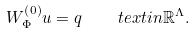<formula> <loc_0><loc_0><loc_500><loc_500>W _ { \Phi } ^ { \left ( 0 \right ) } u = q \, \quad t e x t { i n } \mathbb { R } ^ { \Lambda } .</formula> 